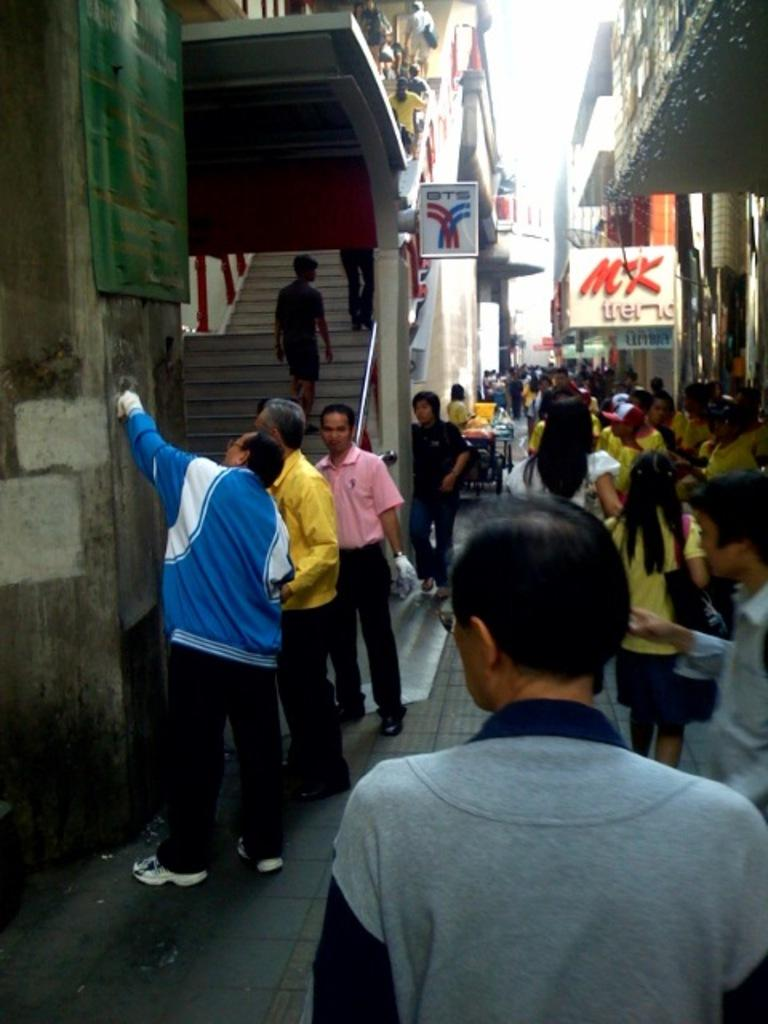How many people are in the image? There is a group of people in the image. What can be seen in the background of the image? There are buildings and name boards in the background of the image. What type of stamp can be seen on the actor's forehead in the image? There is no actor or stamp present in the image. 